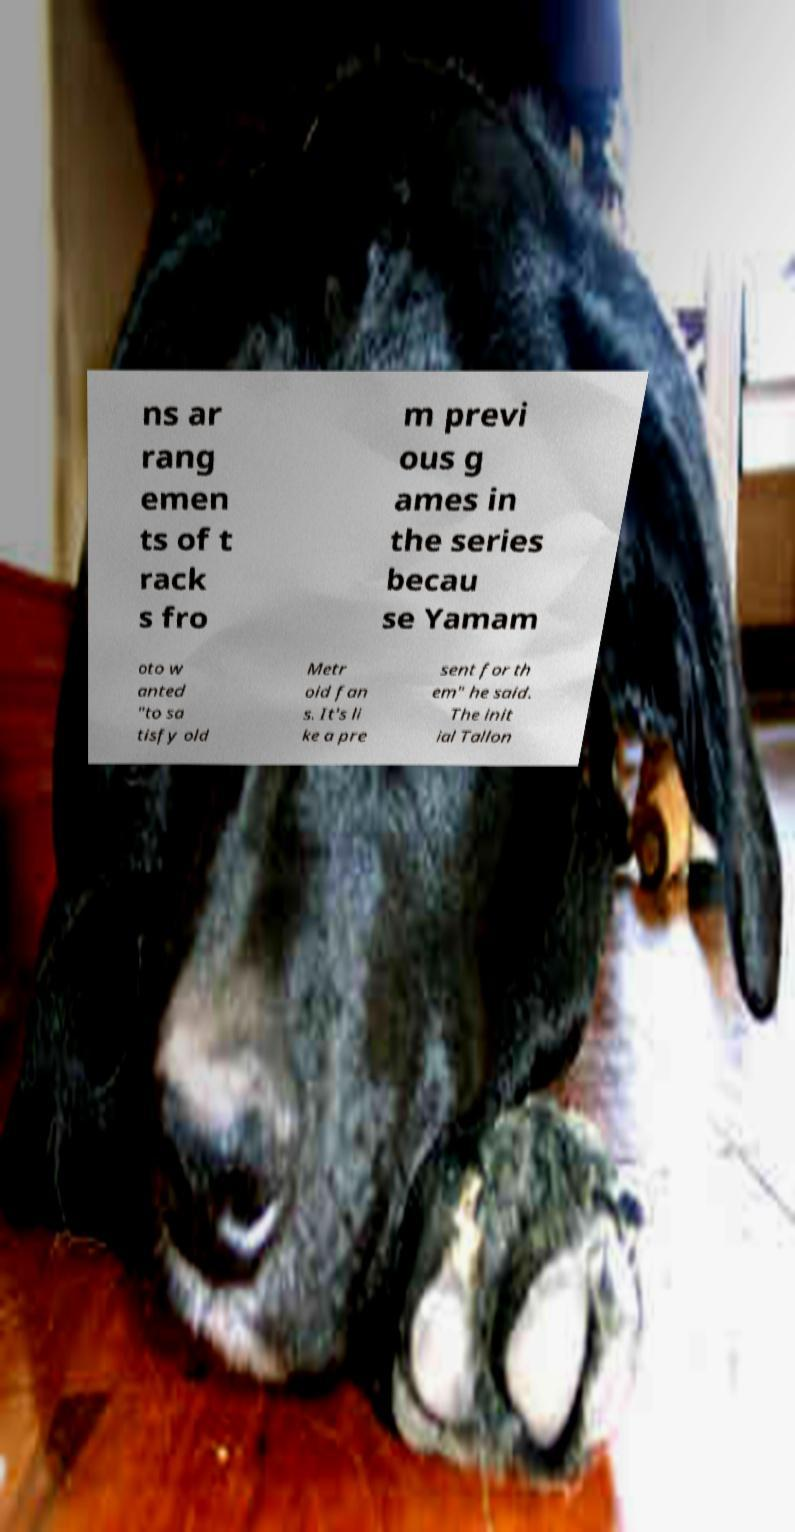Could you assist in decoding the text presented in this image and type it out clearly? ns ar rang emen ts of t rack s fro m previ ous g ames in the series becau se Yamam oto w anted "to sa tisfy old Metr oid fan s. It's li ke a pre sent for th em" he said. The init ial Tallon 